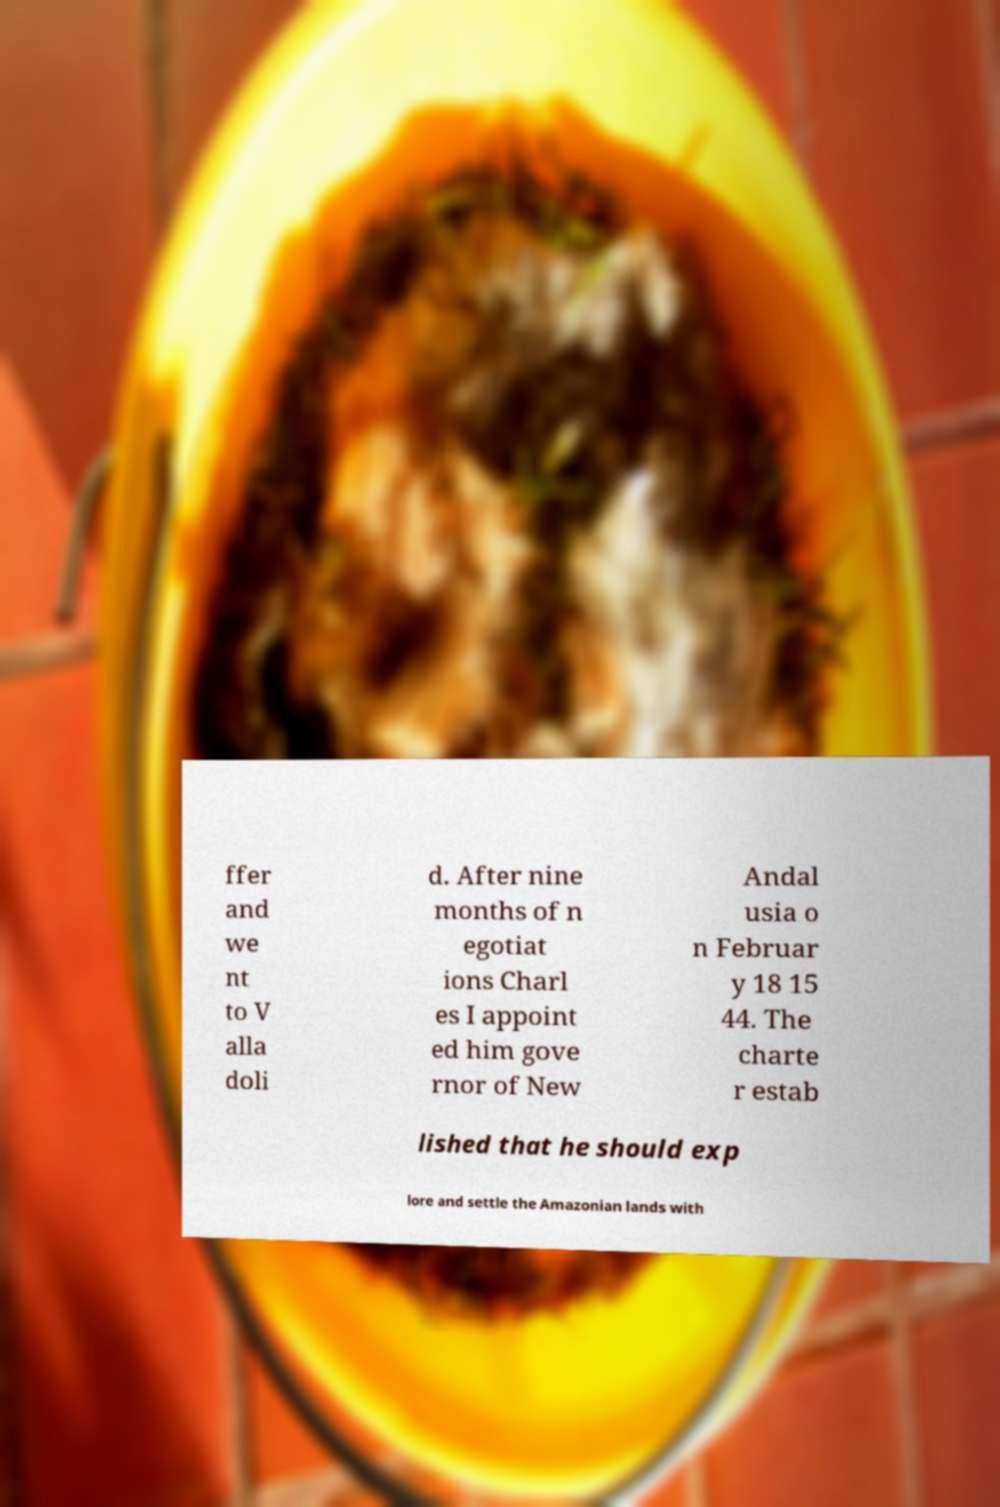For documentation purposes, I need the text within this image transcribed. Could you provide that? ffer and we nt to V alla doli d. After nine months of n egotiat ions Charl es I appoint ed him gove rnor of New Andal usia o n Februar y 18 15 44. The charte r estab lished that he should exp lore and settle the Amazonian lands with 